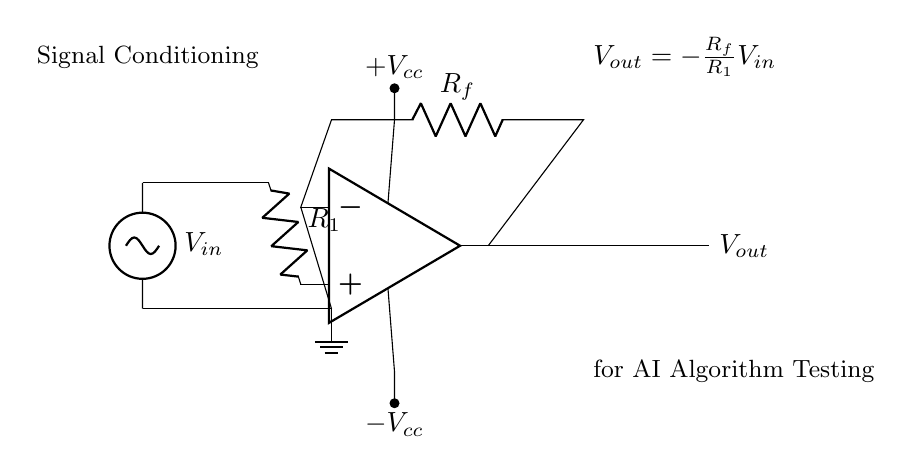What is the input voltage in this circuit? The input voltage denoted as V_in is represented in the circuit diagram with the label at the left side, connecting through the resistor R1 to the operational amplifier.
Answer: V_in What type of circuit is shown in the diagram? The circuit diagram illustrates an operational amplifier circuit specifically designed for signal conditioning, which is evident by the inclusion of an op-amp symbol, input source, feedback resistor, and output.
Answer: Operational amplifier What is the relationship between output voltage and input voltage? The equation provided in the circuit shows that V_out is proportional to V_in, with the proportionality factor defined as the negative ratio of the feedback resistor R_f to the input resistor R1, indicating an inverting configuration commonly found in op-amps.
Answer: V_out equals negative R_f over R_1 times V_in What are the values of the power supply voltages? The schematic shows labels +V_cc and -V_cc indicating the positive and negative supply voltages for the operational amplifier, but the specific numerical values are not provided in the diagram, only their roles as power supplies.
Answer: +V_cc and -V_cc What is the purpose of the feedback resistor in this circuit? The feedback resistor R_f creates a feedback loop from the output to the inverting input of the op-amp, which is crucial for controlling the gain of the amplifier and stabilizing the output signal; it helps set the gain ratio in the output voltage equation.
Answer: Gain control What type of connection exists between the output of the op-amp and the feedback resistor? The connection is a direct short, indicating that the output of the operational amplifier is fed back to the inverting input through the feedback resistor R_f, which helps establish the amplifier's behavior in this configuration.
Answer: Short 